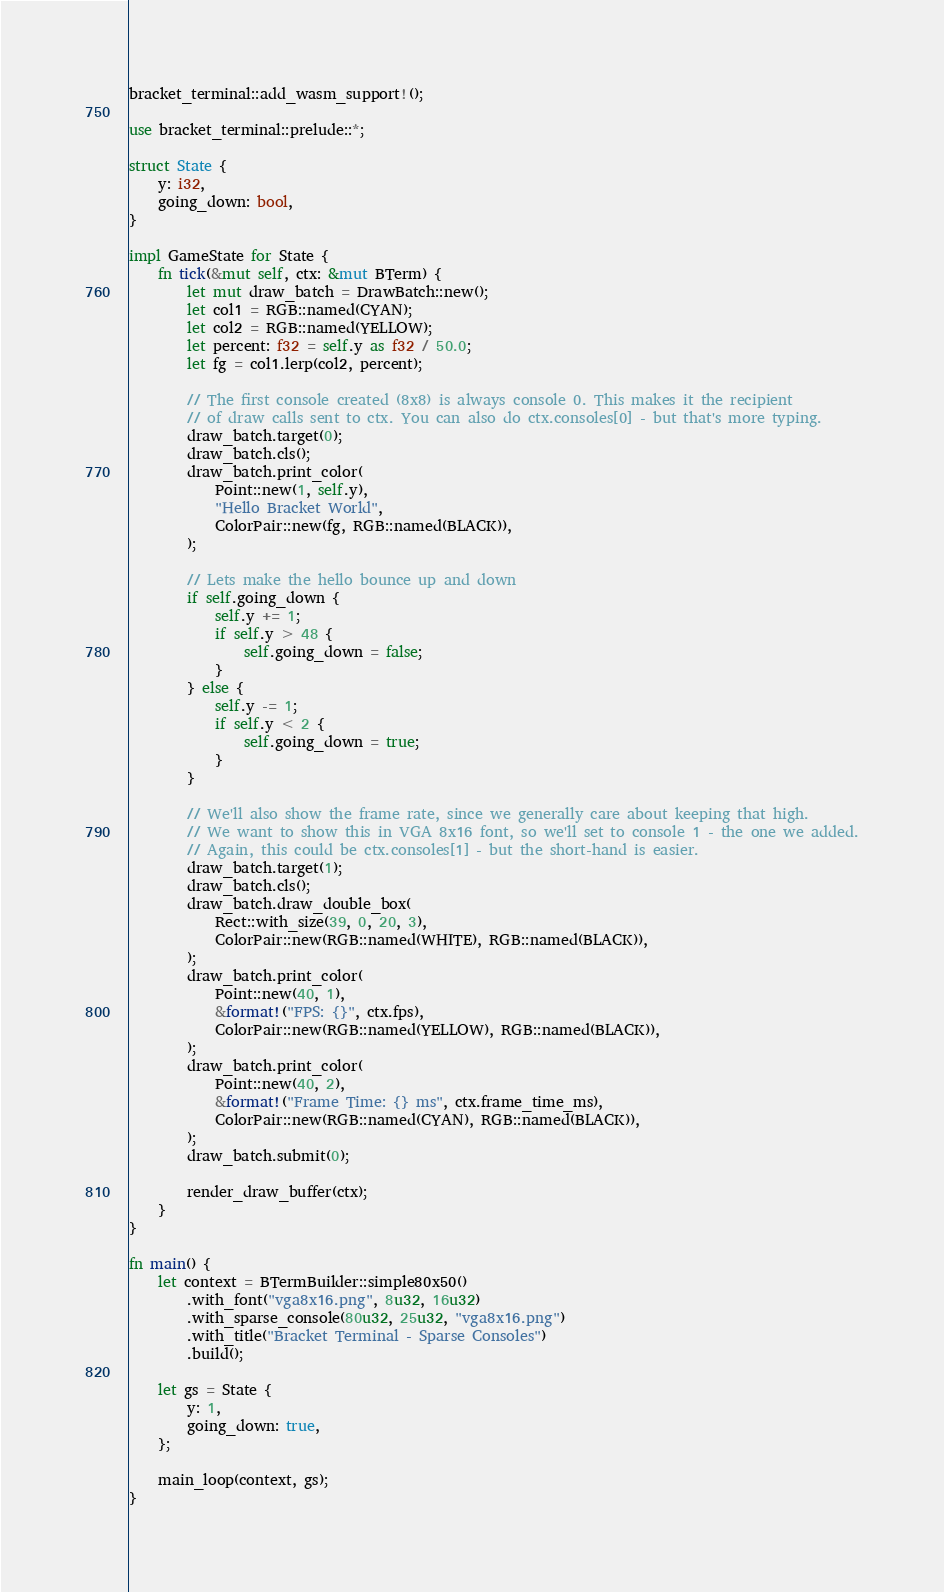Convert code to text. <code><loc_0><loc_0><loc_500><loc_500><_Rust_>bracket_terminal::add_wasm_support!();

use bracket_terminal::prelude::*;

struct State {
    y: i32,
    going_down: bool,
}

impl GameState for State {
    fn tick(&mut self, ctx: &mut BTerm) {
        let mut draw_batch = DrawBatch::new();
        let col1 = RGB::named(CYAN);
        let col2 = RGB::named(YELLOW);
        let percent: f32 = self.y as f32 / 50.0;
        let fg = col1.lerp(col2, percent);

        // The first console created (8x8) is always console 0. This makes it the recipient
        // of draw calls sent to ctx. You can also do ctx.consoles[0] - but that's more typing.
        draw_batch.target(0);
        draw_batch.cls();
        draw_batch.print_color(
            Point::new(1, self.y),
            "Hello Bracket World",
            ColorPair::new(fg, RGB::named(BLACK)),
        );

        // Lets make the hello bounce up and down
        if self.going_down {
            self.y += 1;
            if self.y > 48 {
                self.going_down = false;
            }
        } else {
            self.y -= 1;
            if self.y < 2 {
                self.going_down = true;
            }
        }

        // We'll also show the frame rate, since we generally care about keeping that high.
        // We want to show this in VGA 8x16 font, so we'll set to console 1 - the one we added.
        // Again, this could be ctx.consoles[1] - but the short-hand is easier.
        draw_batch.target(1);
        draw_batch.cls();
        draw_batch.draw_double_box(
            Rect::with_size(39, 0, 20, 3),
            ColorPair::new(RGB::named(WHITE), RGB::named(BLACK)),
        );
        draw_batch.print_color(
            Point::new(40, 1),
            &format!("FPS: {}", ctx.fps),
            ColorPair::new(RGB::named(YELLOW), RGB::named(BLACK)),
        );
        draw_batch.print_color(
            Point::new(40, 2),
            &format!("Frame Time: {} ms", ctx.frame_time_ms),
            ColorPair::new(RGB::named(CYAN), RGB::named(BLACK)),
        );
        draw_batch.submit(0);

        render_draw_buffer(ctx);
    }
}

fn main() {
    let context = BTermBuilder::simple80x50()
        .with_font("vga8x16.png", 8u32, 16u32)
        .with_sparse_console(80u32, 25u32, "vga8x16.png")
        .with_title("Bracket Terminal - Sparse Consoles")
        .build();

    let gs = State {
        y: 1,
        going_down: true,
    };

    main_loop(context, gs);
}
</code> 